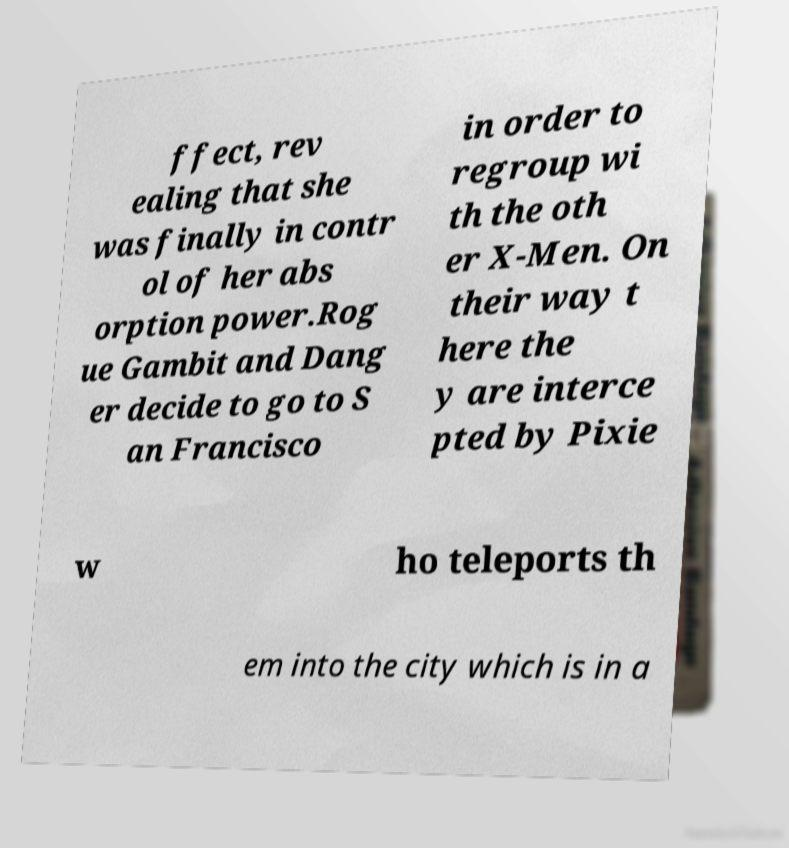Could you assist in decoding the text presented in this image and type it out clearly? ffect, rev ealing that she was finally in contr ol of her abs orption power.Rog ue Gambit and Dang er decide to go to S an Francisco in order to regroup wi th the oth er X-Men. On their way t here the y are interce pted by Pixie w ho teleports th em into the city which is in a 